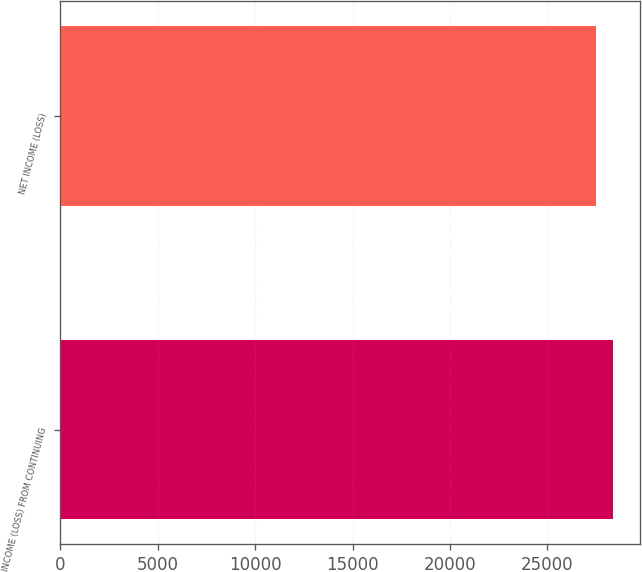Convert chart. <chart><loc_0><loc_0><loc_500><loc_500><bar_chart><fcel>INCOME (LOSS) FROM CONTINUING<fcel>NET INCOME (LOSS)<nl><fcel>28338<fcel>27484<nl></chart> 